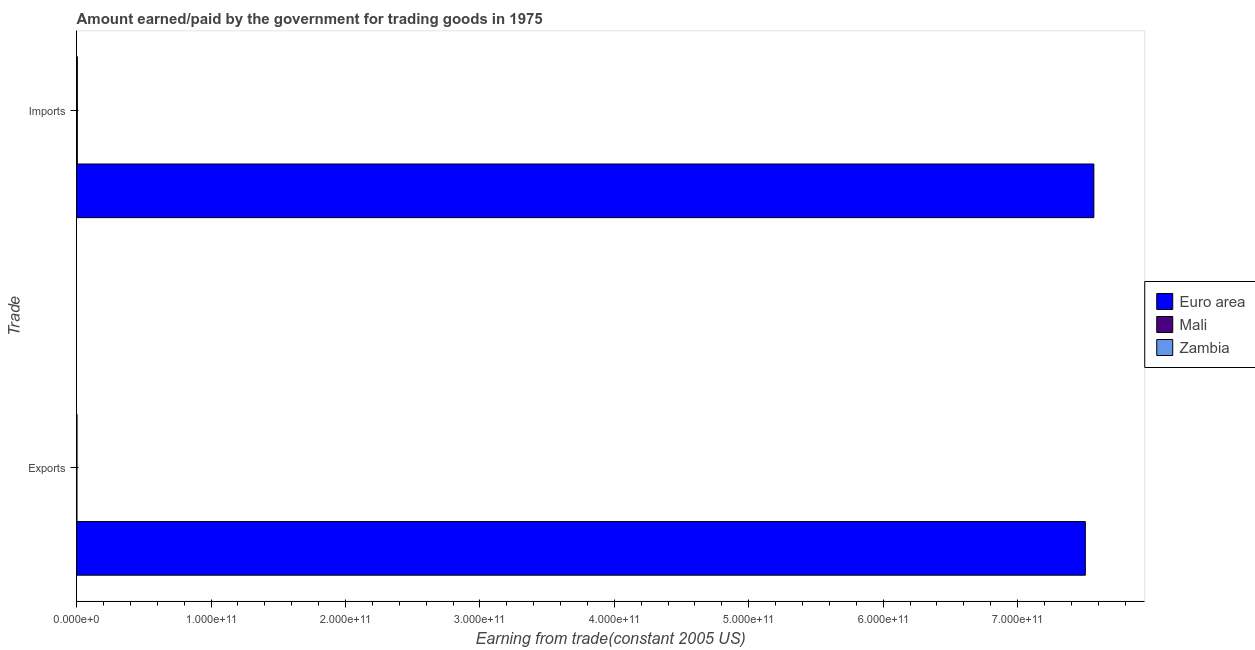Are the number of bars per tick equal to the number of legend labels?
Your response must be concise. Yes. Are the number of bars on each tick of the Y-axis equal?
Keep it short and to the point. Yes. How many bars are there on the 2nd tick from the bottom?
Provide a succinct answer. 3. What is the label of the 1st group of bars from the top?
Offer a terse response. Imports. What is the amount paid for imports in Euro area?
Make the answer very short. 7.57e+11. Across all countries, what is the maximum amount earned from exports?
Ensure brevity in your answer.  7.50e+11. Across all countries, what is the minimum amount earned from exports?
Provide a short and direct response. 2.02e+08. In which country was the amount paid for imports minimum?
Your answer should be compact. Mali. What is the total amount paid for imports in the graph?
Make the answer very short. 7.58e+11. What is the difference between the amount earned from exports in Zambia and that in Euro area?
Your response must be concise. -7.50e+11. What is the difference between the amount paid for imports in Zambia and the amount earned from exports in Euro area?
Provide a succinct answer. -7.50e+11. What is the average amount paid for imports per country?
Your answer should be very brief. 2.53e+11. What is the difference between the amount earned from exports and amount paid for imports in Euro area?
Your answer should be very brief. -6.34e+09. What is the ratio of the amount paid for imports in Euro area to that in Zambia?
Your answer should be compact. 1451.36. Is the amount paid for imports in Euro area less than that in Mali?
Offer a terse response. No. What does the 2nd bar from the top in Imports represents?
Offer a very short reply. Mali. What does the 2nd bar from the bottom in Exports represents?
Give a very brief answer. Mali. What is the difference between two consecutive major ticks on the X-axis?
Provide a succinct answer. 1.00e+11. Are the values on the major ticks of X-axis written in scientific E-notation?
Offer a very short reply. Yes. Does the graph contain grids?
Keep it short and to the point. No. Where does the legend appear in the graph?
Keep it short and to the point. Center right. How are the legend labels stacked?
Your response must be concise. Vertical. What is the title of the graph?
Provide a short and direct response. Amount earned/paid by the government for trading goods in 1975. Does "Azerbaijan" appear as one of the legend labels in the graph?
Make the answer very short. No. What is the label or title of the X-axis?
Provide a short and direct response. Earning from trade(constant 2005 US). What is the label or title of the Y-axis?
Offer a terse response. Trade. What is the Earning from trade(constant 2005 US) of Euro area in Exports?
Offer a terse response. 7.50e+11. What is the Earning from trade(constant 2005 US) of Mali in Exports?
Provide a short and direct response. 2.02e+08. What is the Earning from trade(constant 2005 US) in Zambia in Exports?
Your answer should be compact. 2.50e+08. What is the Earning from trade(constant 2005 US) of Euro area in Imports?
Ensure brevity in your answer.  7.57e+11. What is the Earning from trade(constant 2005 US) of Mali in Imports?
Provide a succinct answer. 4.90e+08. What is the Earning from trade(constant 2005 US) of Zambia in Imports?
Offer a terse response. 5.21e+08. Across all Trade, what is the maximum Earning from trade(constant 2005 US) of Euro area?
Give a very brief answer. 7.57e+11. Across all Trade, what is the maximum Earning from trade(constant 2005 US) in Mali?
Provide a short and direct response. 4.90e+08. Across all Trade, what is the maximum Earning from trade(constant 2005 US) in Zambia?
Provide a short and direct response. 5.21e+08. Across all Trade, what is the minimum Earning from trade(constant 2005 US) in Euro area?
Provide a short and direct response. 7.50e+11. Across all Trade, what is the minimum Earning from trade(constant 2005 US) in Mali?
Keep it short and to the point. 2.02e+08. Across all Trade, what is the minimum Earning from trade(constant 2005 US) in Zambia?
Your answer should be compact. 2.50e+08. What is the total Earning from trade(constant 2005 US) in Euro area in the graph?
Offer a terse response. 1.51e+12. What is the total Earning from trade(constant 2005 US) of Mali in the graph?
Provide a succinct answer. 6.92e+08. What is the total Earning from trade(constant 2005 US) in Zambia in the graph?
Offer a terse response. 7.71e+08. What is the difference between the Earning from trade(constant 2005 US) in Euro area in Exports and that in Imports?
Provide a short and direct response. -6.34e+09. What is the difference between the Earning from trade(constant 2005 US) of Mali in Exports and that in Imports?
Keep it short and to the point. -2.88e+08. What is the difference between the Earning from trade(constant 2005 US) of Zambia in Exports and that in Imports?
Your answer should be compact. -2.72e+08. What is the difference between the Earning from trade(constant 2005 US) in Euro area in Exports and the Earning from trade(constant 2005 US) in Mali in Imports?
Provide a succinct answer. 7.50e+11. What is the difference between the Earning from trade(constant 2005 US) of Euro area in Exports and the Earning from trade(constant 2005 US) of Zambia in Imports?
Ensure brevity in your answer.  7.50e+11. What is the difference between the Earning from trade(constant 2005 US) of Mali in Exports and the Earning from trade(constant 2005 US) of Zambia in Imports?
Give a very brief answer. -3.20e+08. What is the average Earning from trade(constant 2005 US) in Euro area per Trade?
Keep it short and to the point. 7.54e+11. What is the average Earning from trade(constant 2005 US) of Mali per Trade?
Provide a short and direct response. 3.46e+08. What is the average Earning from trade(constant 2005 US) in Zambia per Trade?
Your response must be concise. 3.86e+08. What is the difference between the Earning from trade(constant 2005 US) in Euro area and Earning from trade(constant 2005 US) in Mali in Exports?
Your answer should be very brief. 7.50e+11. What is the difference between the Earning from trade(constant 2005 US) of Euro area and Earning from trade(constant 2005 US) of Zambia in Exports?
Offer a very short reply. 7.50e+11. What is the difference between the Earning from trade(constant 2005 US) in Mali and Earning from trade(constant 2005 US) in Zambia in Exports?
Ensure brevity in your answer.  -4.79e+07. What is the difference between the Earning from trade(constant 2005 US) of Euro area and Earning from trade(constant 2005 US) of Mali in Imports?
Keep it short and to the point. 7.56e+11. What is the difference between the Earning from trade(constant 2005 US) of Euro area and Earning from trade(constant 2005 US) of Zambia in Imports?
Provide a succinct answer. 7.56e+11. What is the difference between the Earning from trade(constant 2005 US) of Mali and Earning from trade(constant 2005 US) of Zambia in Imports?
Provide a short and direct response. -3.16e+07. What is the ratio of the Earning from trade(constant 2005 US) in Euro area in Exports to that in Imports?
Provide a short and direct response. 0.99. What is the ratio of the Earning from trade(constant 2005 US) in Mali in Exports to that in Imports?
Keep it short and to the point. 0.41. What is the ratio of the Earning from trade(constant 2005 US) of Zambia in Exports to that in Imports?
Your response must be concise. 0.48. What is the difference between the highest and the second highest Earning from trade(constant 2005 US) in Euro area?
Ensure brevity in your answer.  6.34e+09. What is the difference between the highest and the second highest Earning from trade(constant 2005 US) in Mali?
Keep it short and to the point. 2.88e+08. What is the difference between the highest and the second highest Earning from trade(constant 2005 US) of Zambia?
Ensure brevity in your answer.  2.72e+08. What is the difference between the highest and the lowest Earning from trade(constant 2005 US) of Euro area?
Your answer should be compact. 6.34e+09. What is the difference between the highest and the lowest Earning from trade(constant 2005 US) of Mali?
Offer a very short reply. 2.88e+08. What is the difference between the highest and the lowest Earning from trade(constant 2005 US) in Zambia?
Make the answer very short. 2.72e+08. 